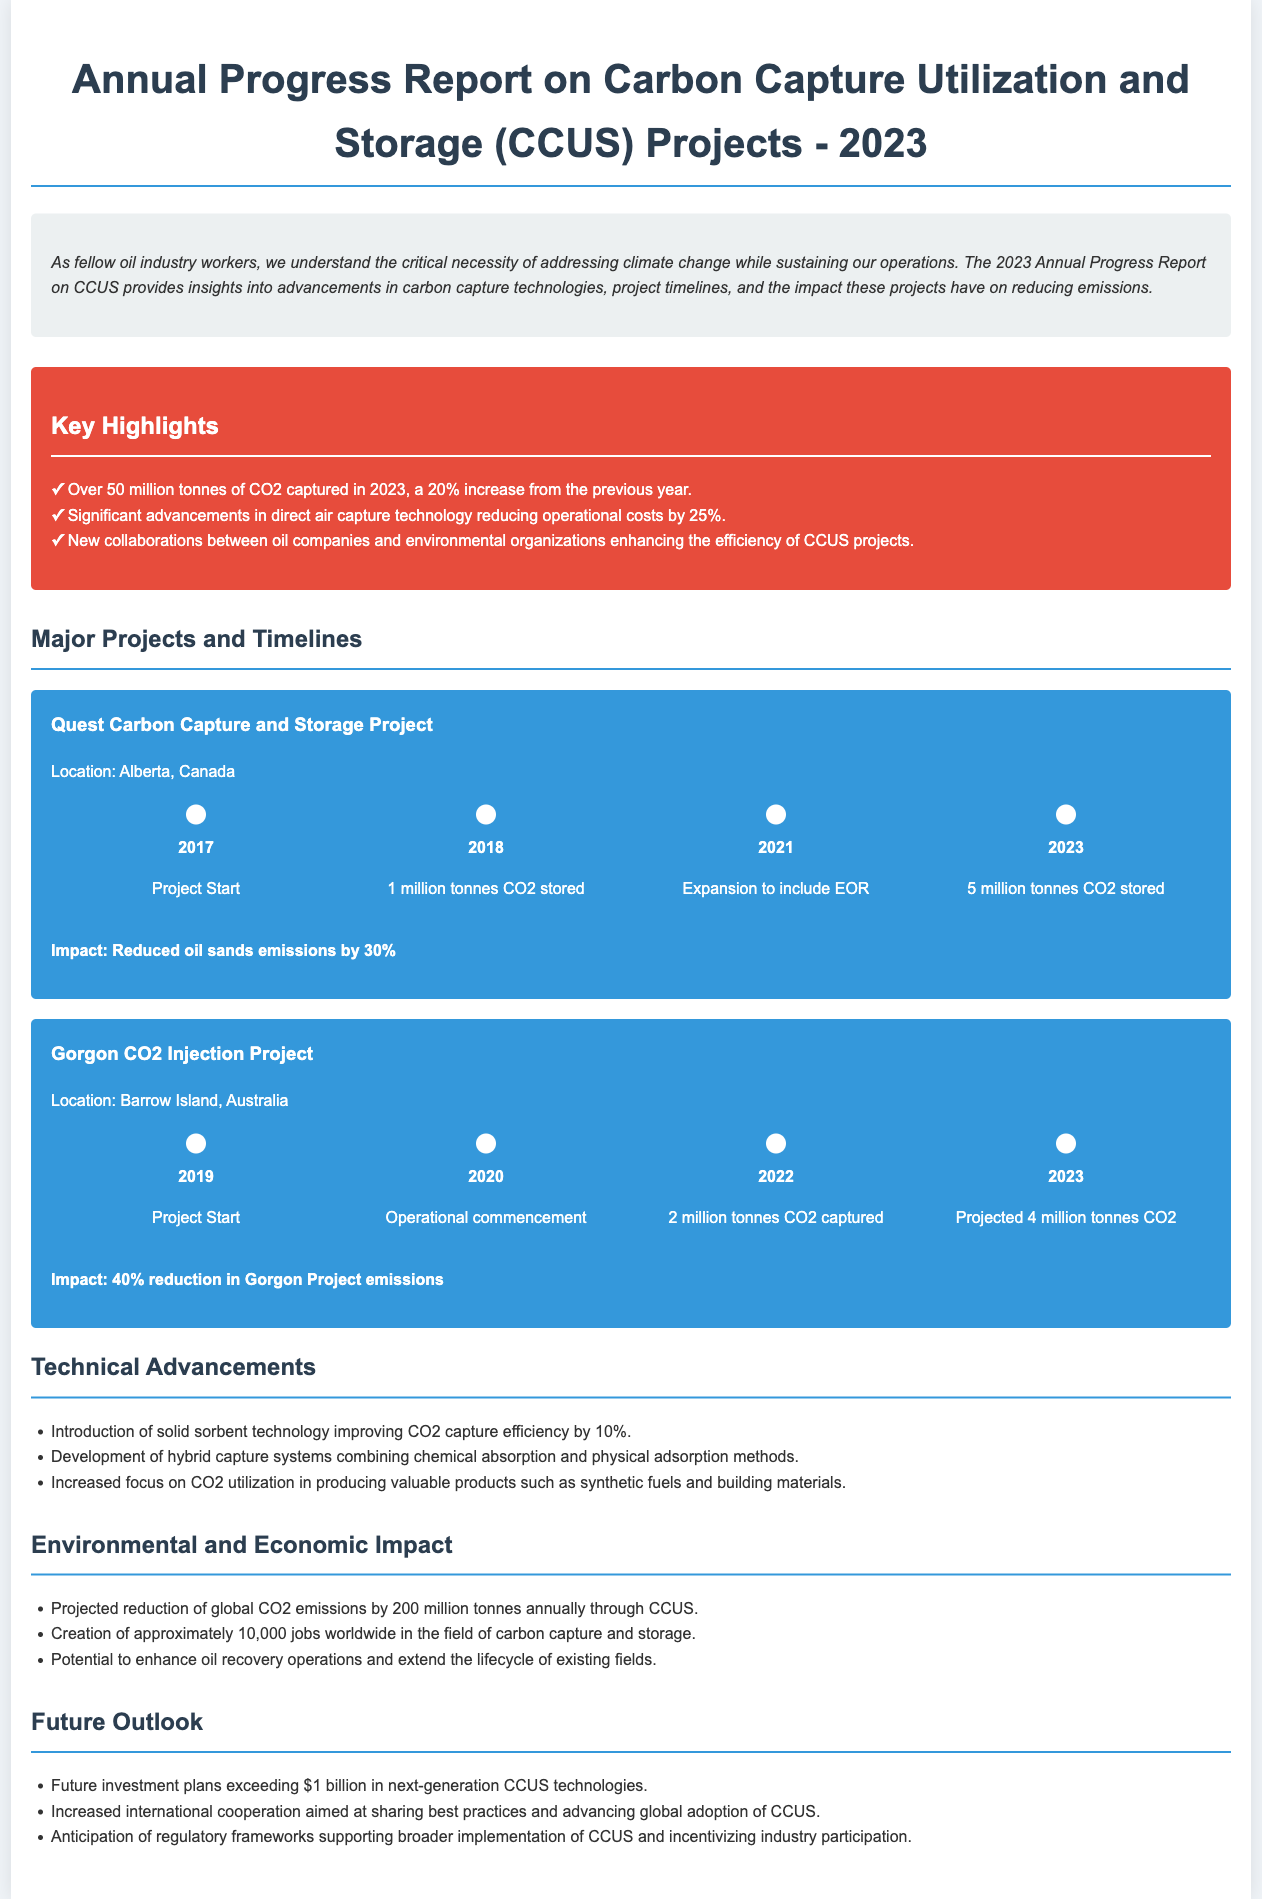what is the total CO2 captured in 2023? The total CO2 captured in 2023 is highlighted as over 50 million tonnes, a 20% increase from the previous year.
Answer: over 50 million tonnes what is the impact of the Quest Carbon Capture and Storage Project? The document states that the impact of the Quest project is a 30% reduction in oil sands emissions.
Answer: 30% which technology reduced operational costs by 25%? The report mentions advancements in direct air capture technology that have reduced operational costs.
Answer: direct air capture technology what year did the Gorgon CO2 Injection Project commence? The Gorgon CO2 Injection Project started in the year 2019.
Answer: 2019 how many jobs were created worldwide through CCUS? According to the report, approximately 10,000 jobs were created worldwide in the field of carbon capture and storage.
Answer: approximately 10,000 jobs what is one of the technical advancements mentioned? The document lists the introduction of solid sorbent technology improving CO2 capture efficiency as a technical advancement.
Answer: solid sorbent technology what is the projected annual reduction of global CO2 emissions through CCUS? The report projects a reduction of global CO2 emissions by 200 million tonnes annually through CCUS.
Answer: 200 million tonnes what collaboration is enhancing the efficiency of CCUS projects? The report highlights new collaborations between oil companies and environmental organizations as enhancing project efficiency.
Answer: oil companies and environmental organizations what is the year when 1 million tonnes CO2 was stored in the Quest project? The milestone for storing 1 million tonnes of CO2 in the Quest project occurred in 2018.
Answer: 2018 